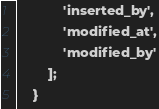Convert code to text. <code><loc_0><loc_0><loc_500><loc_500><_PHP_>            'inserted_by',
            'modified_at',
            'modified_by'
        ];
    }
</code> 